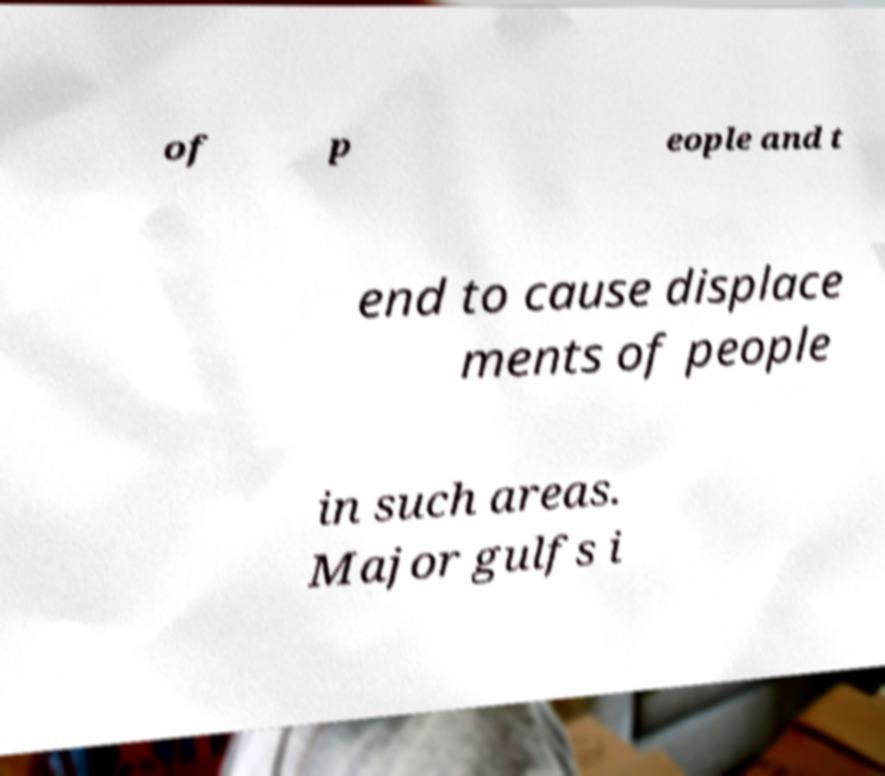I need the written content from this picture converted into text. Can you do that? of p eople and t end to cause displace ments of people in such areas. Major gulfs i 